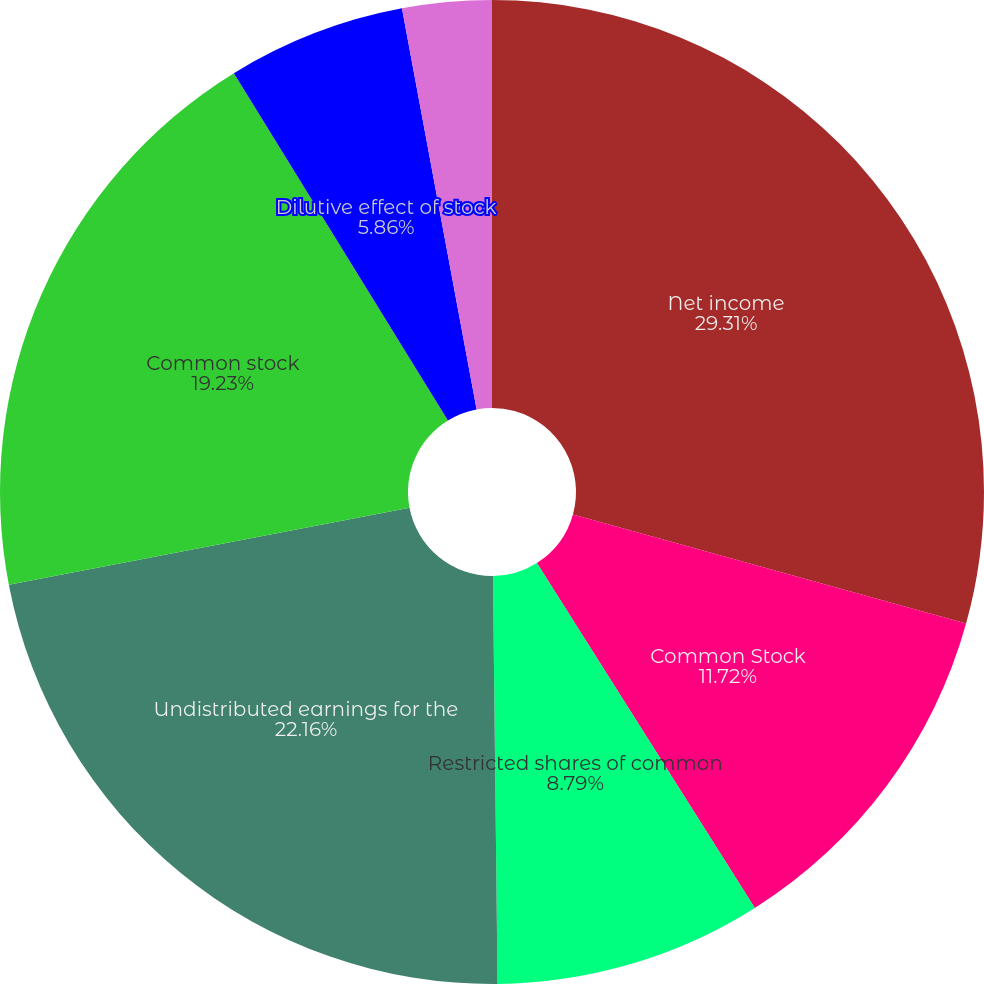<chart> <loc_0><loc_0><loc_500><loc_500><pie_chart><fcel>Net income<fcel>Common Stock<fcel>Restricted shares of common<fcel>Undistributed earnings for the<fcel>Common stock<fcel>Dilutive effect of stock<fcel>Distributed earnings<fcel>Undistributed earnings<nl><fcel>29.31%<fcel>11.72%<fcel>8.79%<fcel>22.16%<fcel>19.23%<fcel>5.86%<fcel>0.0%<fcel>2.93%<nl></chart> 